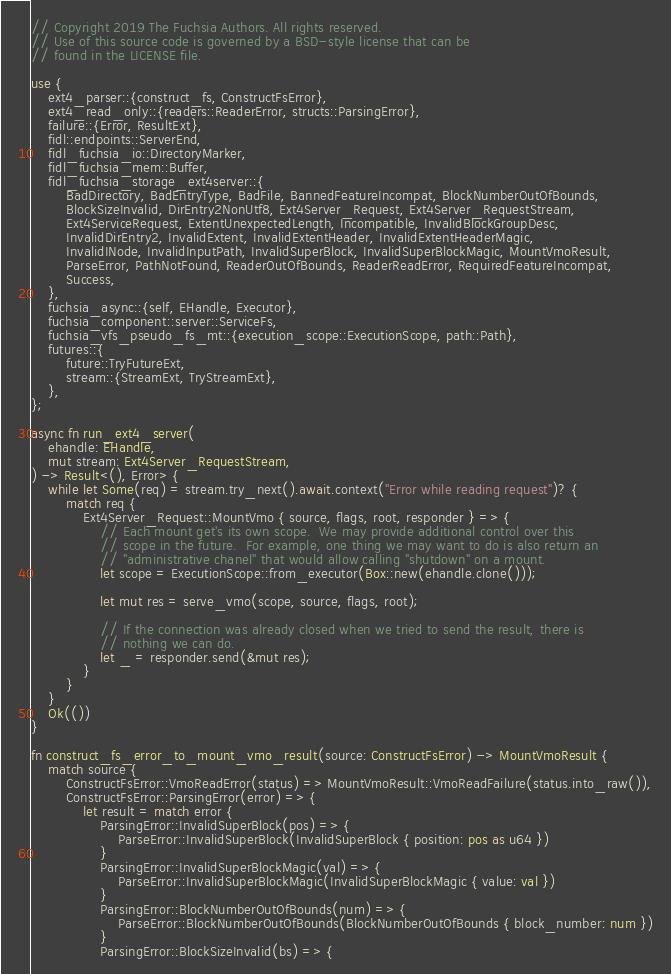<code> <loc_0><loc_0><loc_500><loc_500><_Rust_>// Copyright 2019 The Fuchsia Authors. All rights reserved.
// Use of this source code is governed by a BSD-style license that can be
// found in the LICENSE file.

use {
    ext4_parser::{construct_fs, ConstructFsError},
    ext4_read_only::{readers::ReaderError, structs::ParsingError},
    failure::{Error, ResultExt},
    fidl::endpoints::ServerEnd,
    fidl_fuchsia_io::DirectoryMarker,
    fidl_fuchsia_mem::Buffer,
    fidl_fuchsia_storage_ext4server::{
        BadDirectory, BadEntryType, BadFile, BannedFeatureIncompat, BlockNumberOutOfBounds,
        BlockSizeInvalid, DirEntry2NonUtf8, Ext4Server_Request, Ext4Server_RequestStream,
        Ext4ServiceRequest, ExtentUnexpectedLength, Incompatible, InvalidBlockGroupDesc,
        InvalidDirEntry2, InvalidExtent, InvalidExtentHeader, InvalidExtentHeaderMagic,
        InvalidINode, InvalidInputPath, InvalidSuperBlock, InvalidSuperBlockMagic, MountVmoResult,
        ParseError, PathNotFound, ReaderOutOfBounds, ReaderReadError, RequiredFeatureIncompat,
        Success,
    },
    fuchsia_async::{self, EHandle, Executor},
    fuchsia_component::server::ServiceFs,
    fuchsia_vfs_pseudo_fs_mt::{execution_scope::ExecutionScope, path::Path},
    futures::{
        future::TryFutureExt,
        stream::{StreamExt, TryStreamExt},
    },
};

async fn run_ext4_server(
    ehandle: EHandle,
    mut stream: Ext4Server_RequestStream,
) -> Result<(), Error> {
    while let Some(req) = stream.try_next().await.context("Error while reading request")? {
        match req {
            Ext4Server_Request::MountVmo { source, flags, root, responder } => {
                // Each mount get's its own scope.  We may provide additional control over this
                // scope in the future.  For example, one thing we may want to do is also return an
                // "administrative chanel" that would allow calling "shutdown" on a mount.
                let scope = ExecutionScope::from_executor(Box::new(ehandle.clone()));

                let mut res = serve_vmo(scope, source, flags, root);

                // If the connection was already closed when we tried to send the result, there is
                // nothing we can do.
                let _ = responder.send(&mut res);
            }
        }
    }
    Ok(())
}

fn construct_fs_error_to_mount_vmo_result(source: ConstructFsError) -> MountVmoResult {
    match source {
        ConstructFsError::VmoReadError(status) => MountVmoResult::VmoReadFailure(status.into_raw()),
        ConstructFsError::ParsingError(error) => {
            let result = match error {
                ParsingError::InvalidSuperBlock(pos) => {
                    ParseError::InvalidSuperBlock(InvalidSuperBlock { position: pos as u64 })
                }
                ParsingError::InvalidSuperBlockMagic(val) => {
                    ParseError::InvalidSuperBlockMagic(InvalidSuperBlockMagic { value: val })
                }
                ParsingError::BlockNumberOutOfBounds(num) => {
                    ParseError::BlockNumberOutOfBounds(BlockNumberOutOfBounds { block_number: num })
                }
                ParsingError::BlockSizeInvalid(bs) => {</code> 